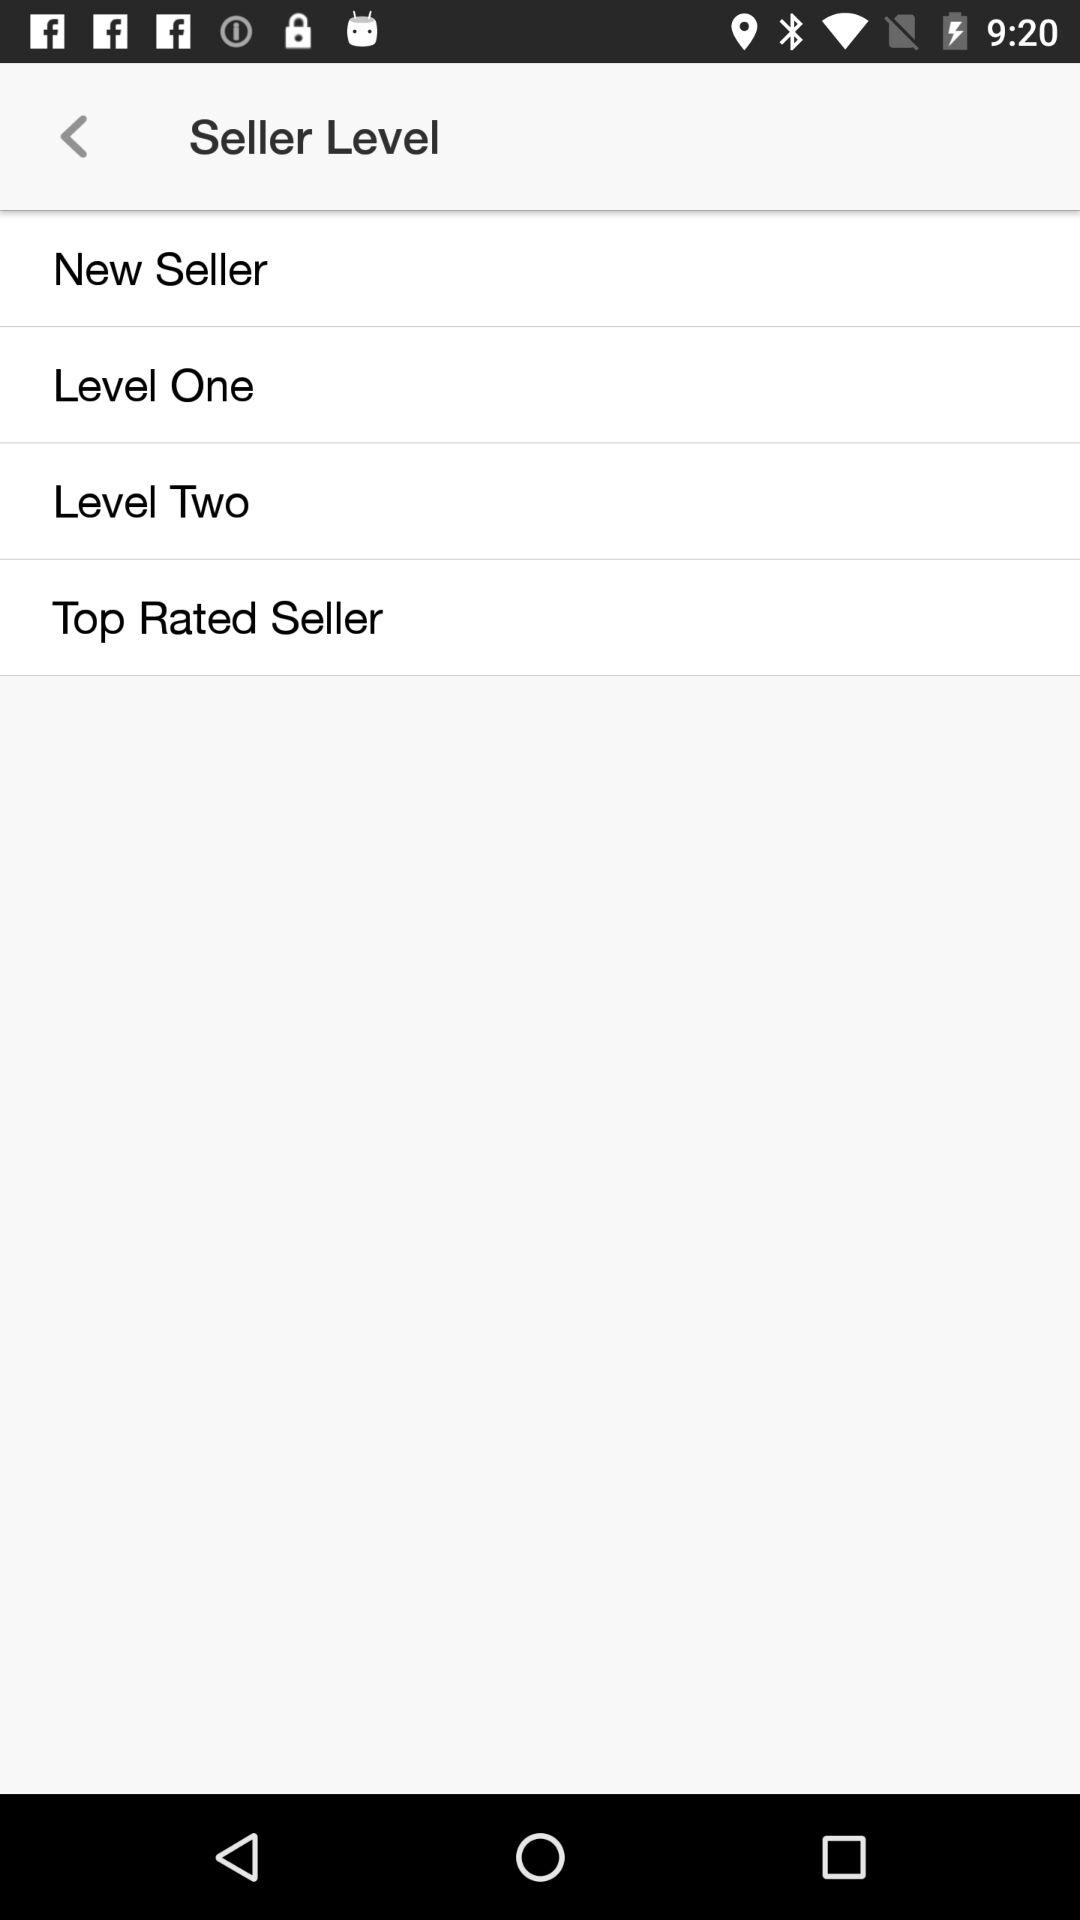What are the given seller levels? The given seller levels are "New Seller", "Level One", "Level Two" and "Top Rated Seller". 